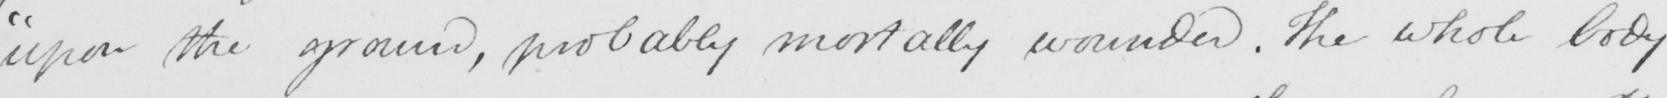What is written in this line of handwriting? " upon the ground , probably mortally wounded . The whole body 